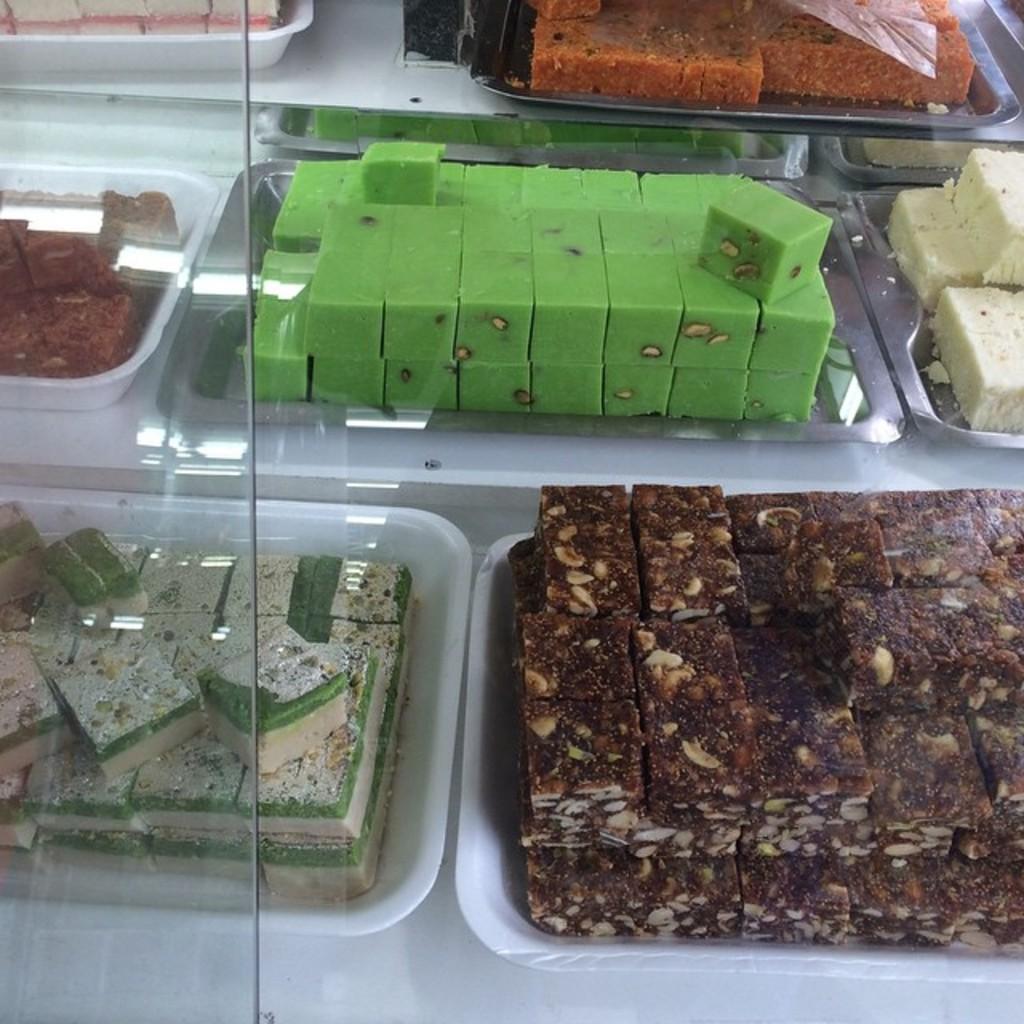In one or two sentences, can you explain what this image depicts? In this picture, we can see a glass and behind the glass there are different kinds of sweets on the plates. 